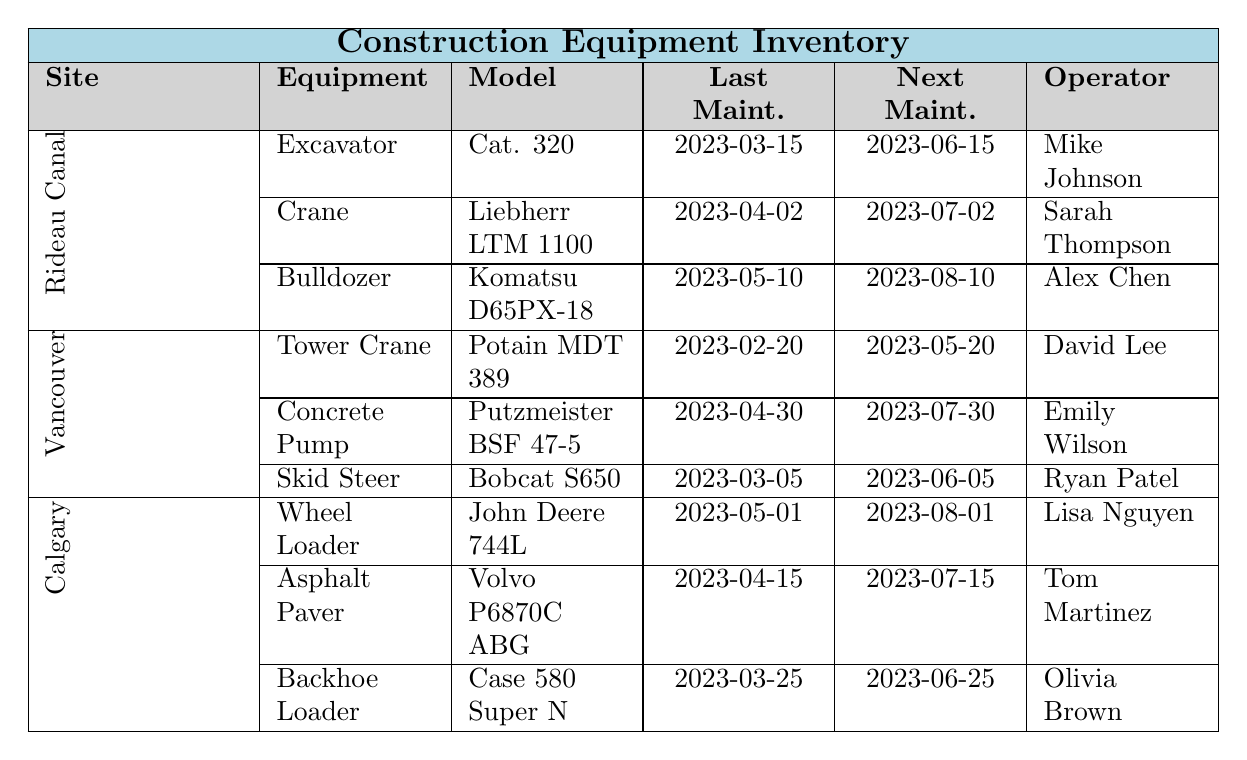What is the last maintenance date for the Bulldozer at the Rideau Canal project? The table lists the equipment for the Rideau Canal project, where the Bulldozer's last maintenance date is specified as 2023-05-10.
Answer: 2023-05-10 Who is the operator of the Tower Crane in Vancouver? In the table, the Tower Crane is listed under the Vancouver site, and the operator is mentioned as David Lee.
Answer: David Lee When is the next maintenance scheduled for the Concrete Pump in Vancouver? The next maintenance date for the Concrete Pump at the Vancouver site is specified in the table as 2023-07-30.
Answer: 2023-07-30 How many pieces of equipment are listed for the Calgary International Airport Expansion site? The table shows that there are three pieces of equipment for the Calgary International Airport Expansion site: Wheel Loader, Asphalt Paver, and Backhoe Loader.
Answer: 3 What model of equipment is scheduled for maintenance after the Excavator in Rideau Canal? The Excavator is scheduled for maintenance on 2023-06-15, followed by the Crane on 2023-07-02.
Answer: Crane Is the last maintenance for the Skid Steer Loader in Vancouver more recent than the last maintenance for the Wheel Loader in Calgary? The Skid Steer Loader's last maintenance date is 2023-03-05, while the Wheel Loader's last maintenance date is 2023-05-01. Since 2023-05-01 is more recent, the answer is No.
Answer: No Which construction site has an equipment operator named Alex Chen? Looking at the table, Alex Chen is the operator of the Bulldozer which belongs to the Rideau Canal project.
Answer: Rideau Canal Condo Project What is the average time between the last maintenance and next maintenance for all the equipment listed at the Calgary site? The last and next maintenance dates for equipment at Calgary are 2023-05-01, 2023-04-15, and 2023-03-25 respectively, with the next maintenance dates of 2023-08-01, 2023-07-15, and 2023-06-25. The intervals are 3 months (May-Aug), 3 months (Apr-Jul), and 3 months (Mar-Jun), averaging to (3+3+3)/3 = 3 months.
Answer: 3 months Which equipment at the Vancouver site has the earliest last maintenance date? In the Vancouver site, the Tower Crane has the earliest last maintenance date of 2023-02-20, compared to other equipment listed at this site.
Answer: Tower Crane What type of equipment scheduled for next maintenance in June at the Rideau Canal site? Examining the next maintenance dates at the Rideau Canal site, the Excavator and Bulldozer have their next maintenance scheduled for June (2023-06-15 and 2023-08-10 respectively). So the answer includes Excavator only.
Answer: Excavator 